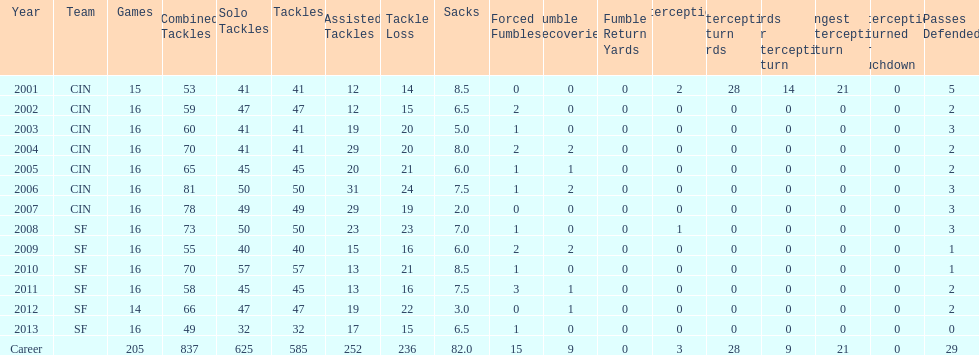How many sacks did this player have in his first five seasons? 34. 